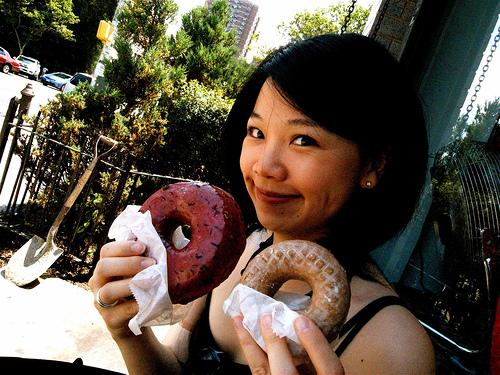How many fingernails are visible?
Short answer required. 5. How many doughnuts is she holding?
Keep it brief. 2. What is leaning against the fence?
Quick response, please. Shovel. Is it a hot day?
Be succinct. Yes. 